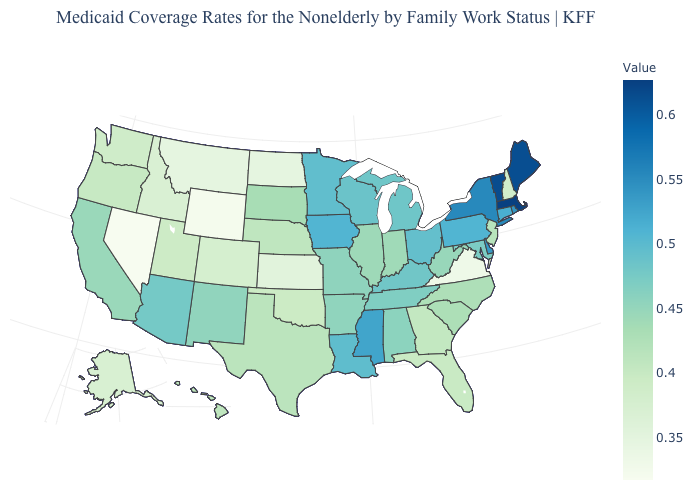Among the states that border Utah , does Arizona have the highest value?
Keep it brief. Yes. Does the map have missing data?
Be succinct. No. Does Arkansas have the lowest value in the South?
Short answer required. No. Does Illinois have the lowest value in the MidWest?
Write a very short answer. No. Does Massachusetts have the highest value in the Northeast?
Write a very short answer. Yes. 